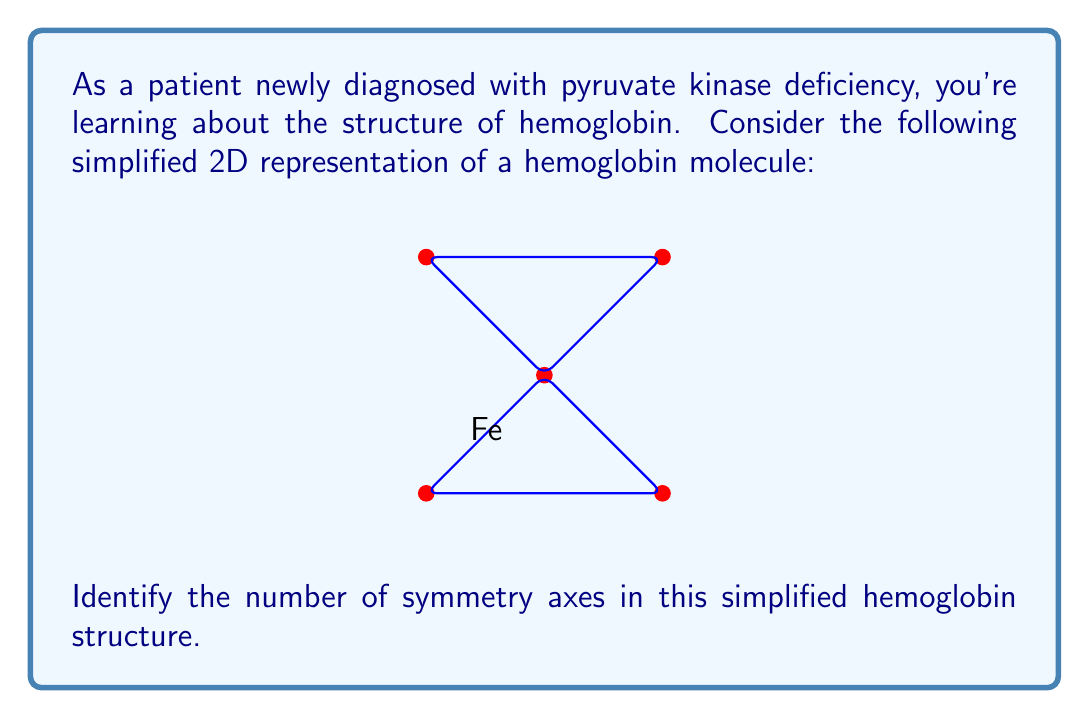Solve this math problem. To identify the symmetry axes in this simplified hemoglobin structure, we need to consider lines that divide the structure into two identical halves. Let's analyze the structure step-by-step:

1. The structure is composed of a central iron (Fe) atom with four surrounding points forming a cross-like shape.

2. Vertical axis: There is a vertical line passing through the iron atom that divides the structure into two identical halves (left and right).

3. Horizontal axis: There is a horizontal line passing through the iron atom that divides the structure into two identical halves (top and bottom).

4. Diagonal axes: There are two diagonal lines passing through the iron atom, each connecting opposite corners of the cross. These lines also divide the structure into two identical halves.

5. Count the symmetry axes:
   - 1 vertical axis
   - 1 horizontal axis
   - 2 diagonal axes

Therefore, the total number of symmetry axes in this simplified hemoglobin structure is 4.

This symmetry analysis helps in understanding the molecular structure of hemoglobin, which is crucial for patients with pyruvate kinase deficiency as it affects red blood cells and oxygen transport.
Answer: 4 